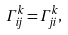<formula> <loc_0><loc_0><loc_500><loc_500>\Gamma ^ { k } _ { i j } = \Gamma ^ { k } _ { j i } , \quad \\</formula> 